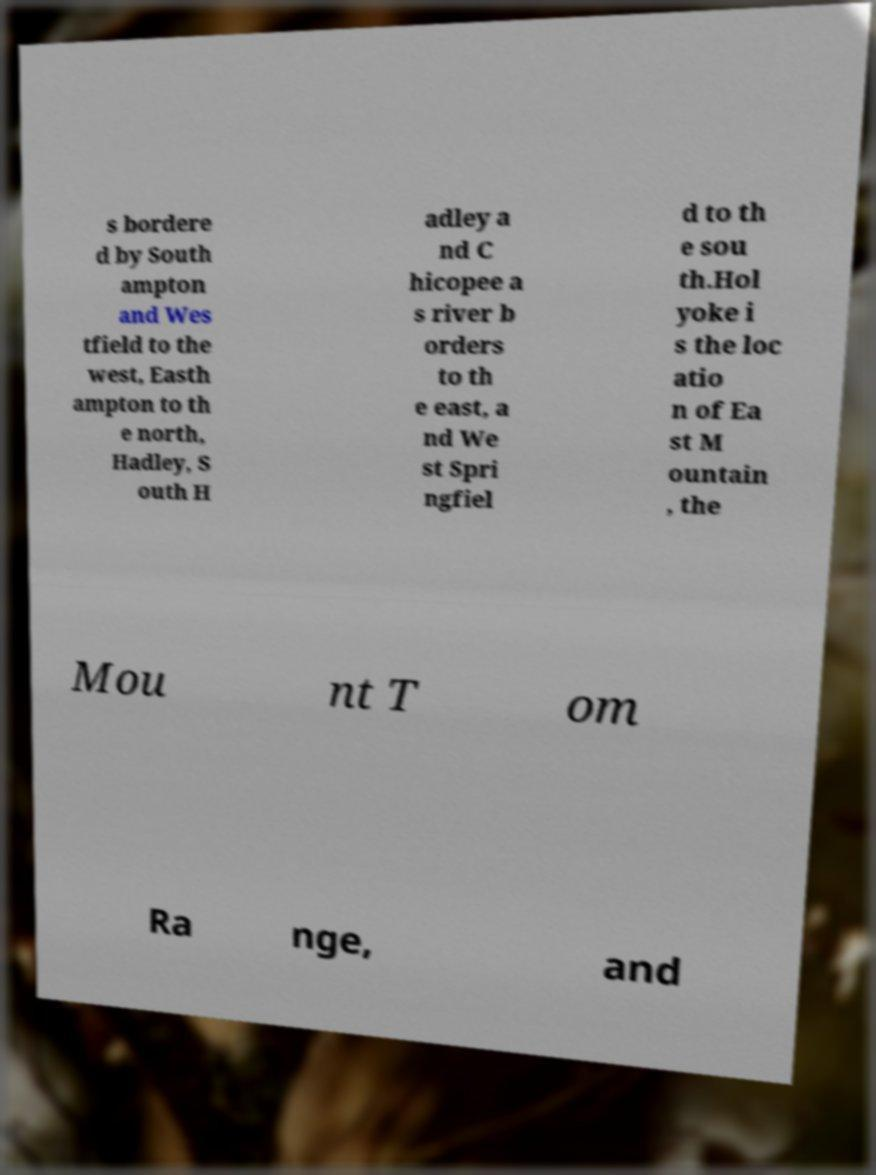Please identify and transcribe the text found in this image. s bordere d by South ampton and Wes tfield to the west, Easth ampton to th e north, Hadley, S outh H adley a nd C hicopee a s river b orders to th e east, a nd We st Spri ngfiel d to th e sou th.Hol yoke i s the loc atio n of Ea st M ountain , the Mou nt T om Ra nge, and 